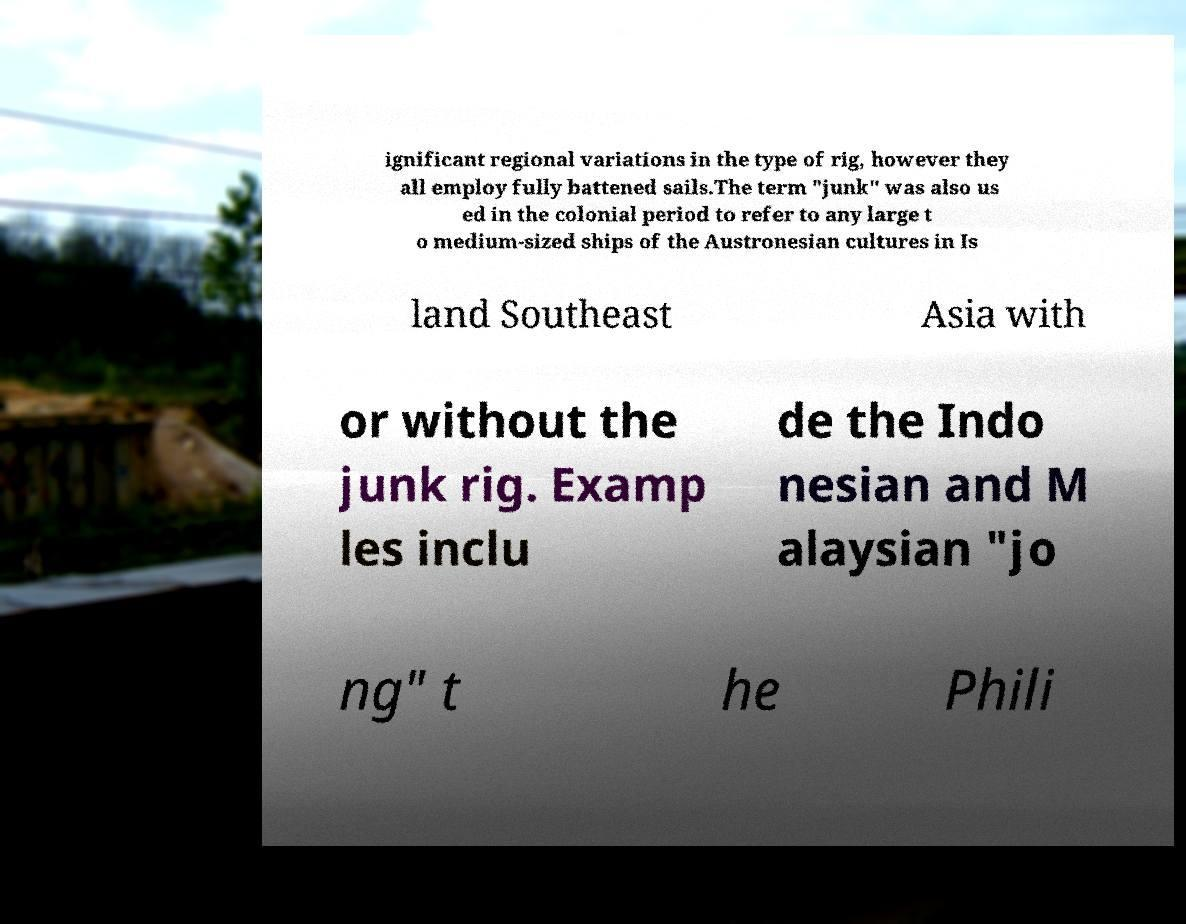Can you accurately transcribe the text from the provided image for me? ignificant regional variations in the type of rig, however they all employ fully battened sails.The term "junk" was also us ed in the colonial period to refer to any large t o medium-sized ships of the Austronesian cultures in Is land Southeast Asia with or without the junk rig. Examp les inclu de the Indo nesian and M alaysian "jo ng" t he Phili 